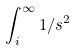Convert formula to latex. <formula><loc_0><loc_0><loc_500><loc_500>\int _ { i } ^ { \infty } 1 / s ^ { 2 }</formula> 